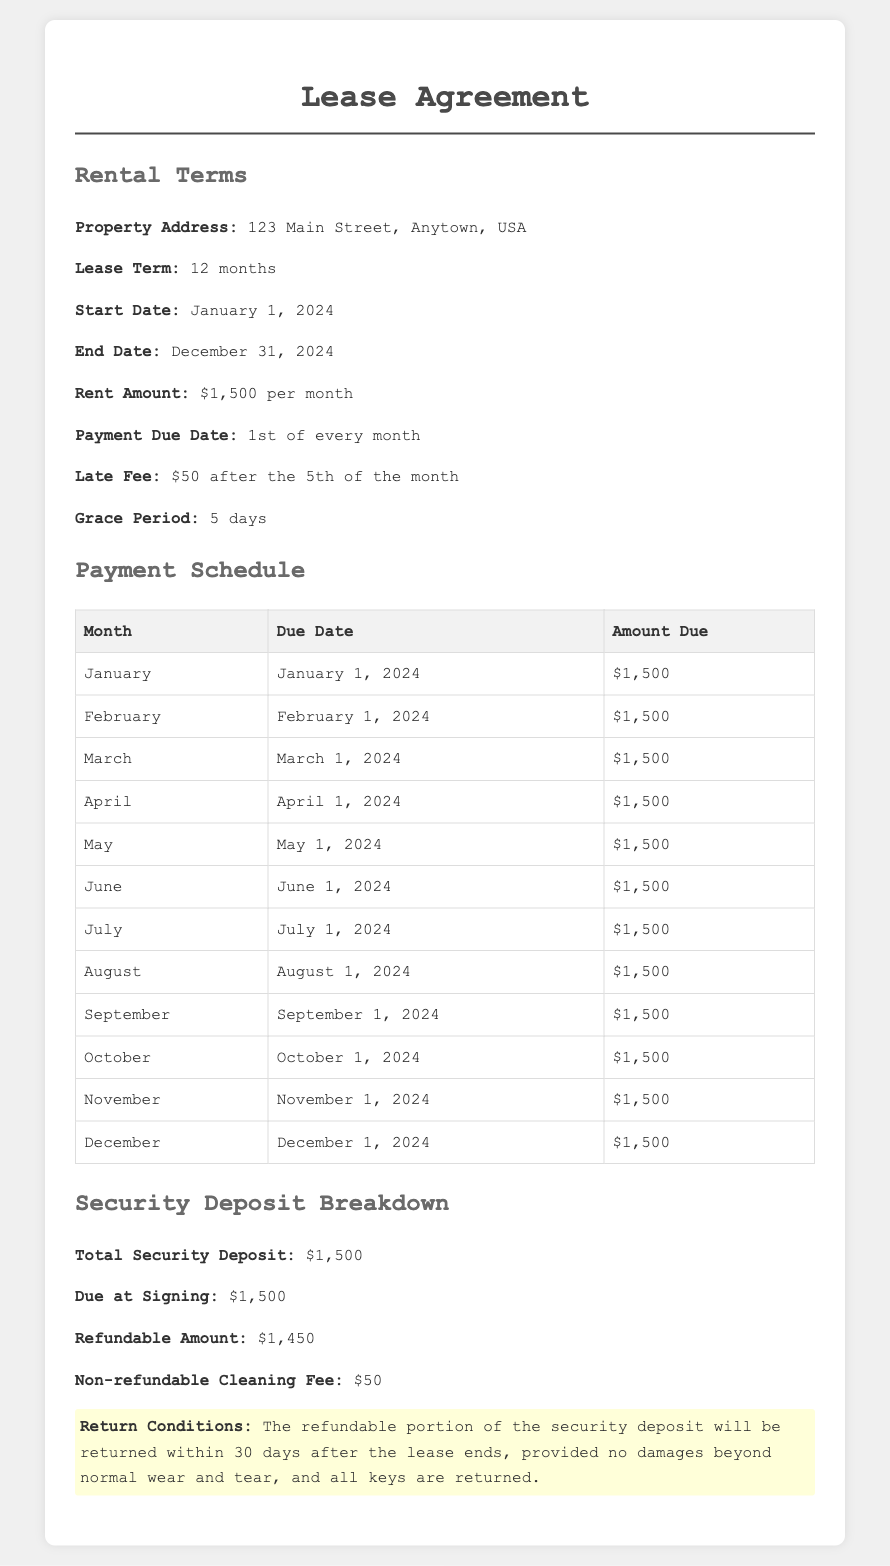What is the property address? The property address is listed under the rental terms section of the document.
Answer: 123 Main Street, Anytown, USA What is the lease term? The lease term specifies the duration of the rental agreement found in the rental terms section.
Answer: 12 months When does the lease start? The start date of the lease is provided in the rental terms section of the document.
Answer: January 1, 2024 What is the monthly rent amount? The rent amount is clearly stated in the rental terms section of the document.
Answer: $1,500 What is the late fee amount? The late fee is mentioned along with payment terms in the rental terms section.
Answer: $50 How many days is the grace period? The grace period is specified in the rental terms section of the document.
Answer: 5 days What is the refundable amount of the security deposit? This information is provided in the security deposit breakdown section of the document.
Answer: $1,450 What is the non-refundable cleaning fee? The non-refundable cleaning fee is clearly stated in the security deposit breakdown section.
Answer: $50 When will the refundable portion of the security deposit be returned? The return conditions provide details on the time frame for the refundable portion in the security deposit breakdown.
Answer: Within 30 days after the lease ends 